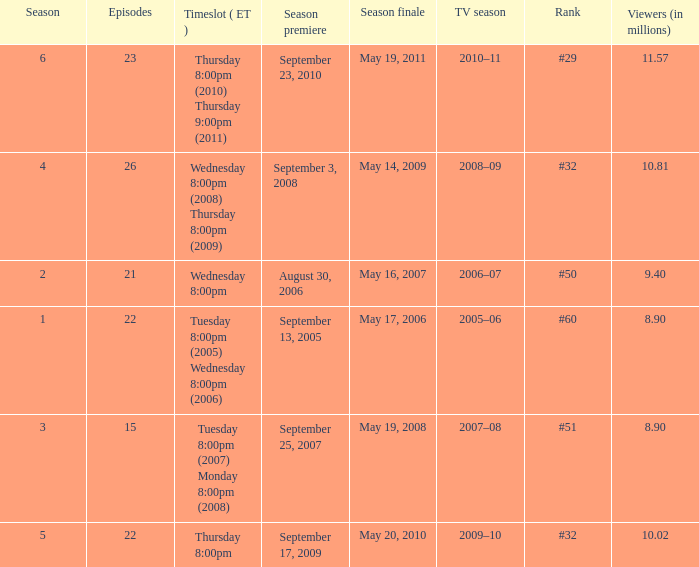How many seasons was the rank equal to #50? 1.0. 